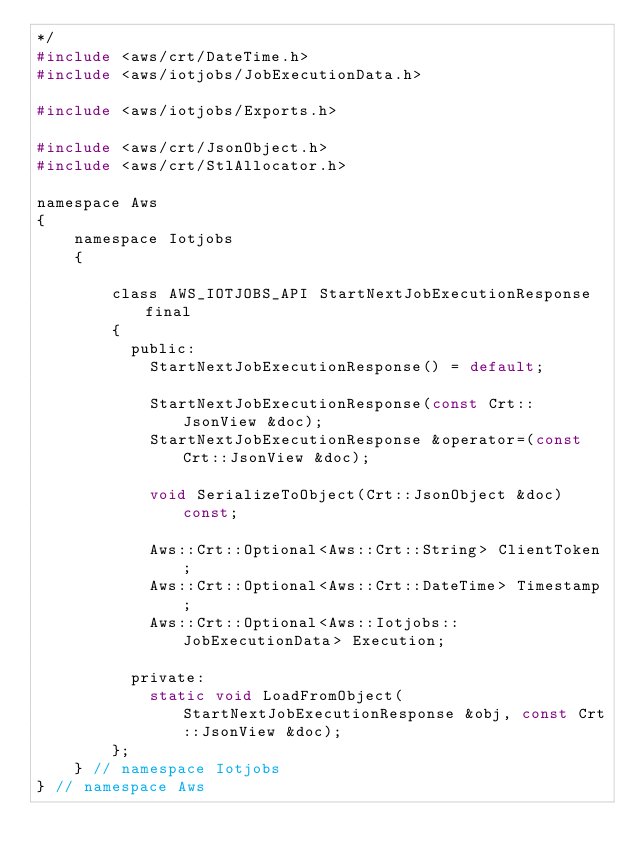Convert code to text. <code><loc_0><loc_0><loc_500><loc_500><_C_>*/
#include <aws/crt/DateTime.h>
#include <aws/iotjobs/JobExecutionData.h>

#include <aws/iotjobs/Exports.h>

#include <aws/crt/JsonObject.h>
#include <aws/crt/StlAllocator.h>

namespace Aws
{
    namespace Iotjobs
    {

        class AWS_IOTJOBS_API StartNextJobExecutionResponse final
        {
          public:
            StartNextJobExecutionResponse() = default;

            StartNextJobExecutionResponse(const Crt::JsonView &doc);
            StartNextJobExecutionResponse &operator=(const Crt::JsonView &doc);

            void SerializeToObject(Crt::JsonObject &doc) const;

            Aws::Crt::Optional<Aws::Crt::String> ClientToken;
            Aws::Crt::Optional<Aws::Crt::DateTime> Timestamp;
            Aws::Crt::Optional<Aws::Iotjobs::JobExecutionData> Execution;

          private:
            static void LoadFromObject(StartNextJobExecutionResponse &obj, const Crt::JsonView &doc);
        };
    } // namespace Iotjobs
} // namespace Aws
</code> 